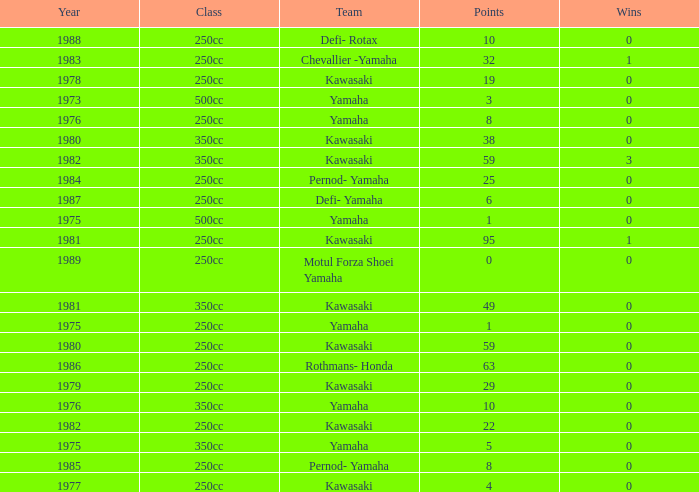How many points numbers had a class of 250cc, a year prior to 1978, Yamaha as a team, and where wins was more than 0? 0.0. Help me parse the entirety of this table. {'header': ['Year', 'Class', 'Team', 'Points', 'Wins'], 'rows': [['1988', '250cc', 'Defi- Rotax', '10', '0'], ['1983', '250cc', 'Chevallier -Yamaha', '32', '1'], ['1978', '250cc', 'Kawasaki', '19', '0'], ['1973', '500cc', 'Yamaha', '3', '0'], ['1976', '250cc', 'Yamaha', '8', '0'], ['1980', '350cc', 'Kawasaki', '38', '0'], ['1982', '350cc', 'Kawasaki', '59', '3'], ['1984', '250cc', 'Pernod- Yamaha', '25', '0'], ['1987', '250cc', 'Defi- Yamaha', '6', '0'], ['1975', '500cc', 'Yamaha', '1', '0'], ['1981', '250cc', 'Kawasaki', '95', '1'], ['1989', '250cc', 'Motul Forza Shoei Yamaha', '0', '0'], ['1981', '350cc', 'Kawasaki', '49', '0'], ['1975', '250cc', 'Yamaha', '1', '0'], ['1980', '250cc', 'Kawasaki', '59', '0'], ['1986', '250cc', 'Rothmans- Honda', '63', '0'], ['1979', '250cc', 'Kawasaki', '29', '0'], ['1976', '350cc', 'Yamaha', '10', '0'], ['1982', '250cc', 'Kawasaki', '22', '0'], ['1975', '350cc', 'Yamaha', '5', '0'], ['1985', '250cc', 'Pernod- Yamaha', '8', '0'], ['1977', '250cc', 'Kawasaki', '4', '0']]} 